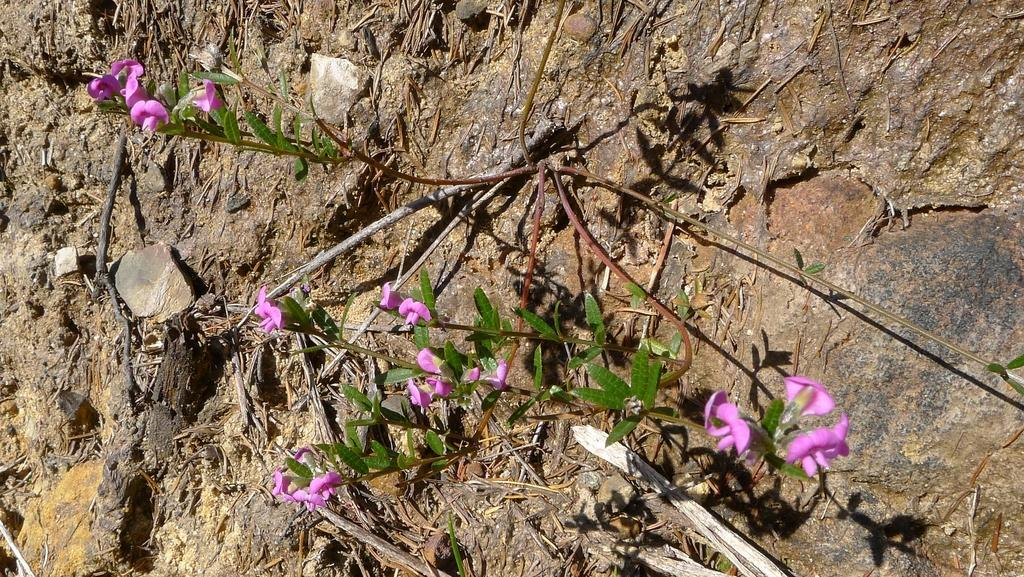What type of plant can be seen in the image? There is a plant with flowers in the image. What part of the plant is visible on the surface? The plant has roots visible on the surface. What other natural elements can be seen in the image? Dry branches, stones, and rocks are visible in the image. What type of star can be seen in the image? There is no star present in the image; it features a plant with flowers, roots, dry branches, stones, and rocks. Who is the creator of the plant in the image? The image does not provide information about the creator of the plant; it only shows the plant and its surroundings. 